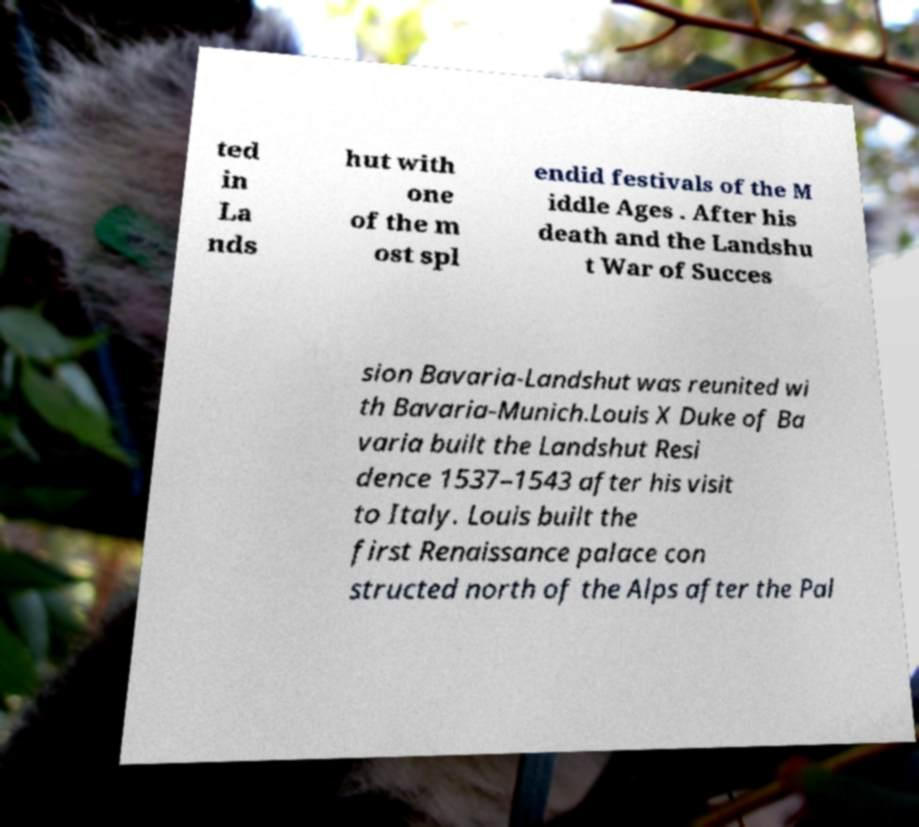For documentation purposes, I need the text within this image transcribed. Could you provide that? ted in La nds hut with one of the m ost spl endid festivals of the M iddle Ages . After his death and the Landshu t War of Succes sion Bavaria-Landshut was reunited wi th Bavaria-Munich.Louis X Duke of Ba varia built the Landshut Resi dence 1537–1543 after his visit to Italy. Louis built the first Renaissance palace con structed north of the Alps after the Pal 